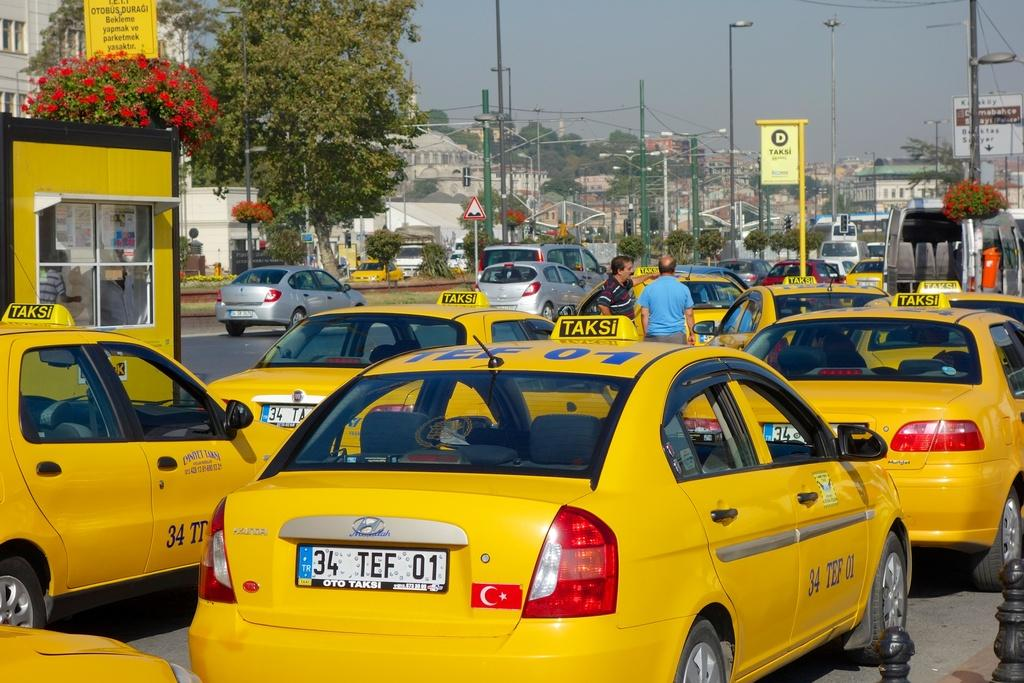<image>
Share a concise interpretation of the image provided. A taxi has TEF 01 written in blue on its roof. 